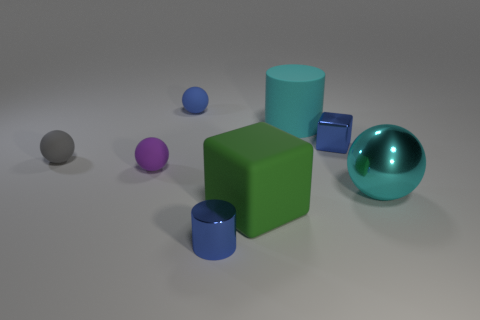Subtract all blue spheres. How many spheres are left? 3 Subtract all cylinders. How many objects are left? 6 Add 1 cyan balls. How many objects exist? 9 Subtract all cyan balls. How many balls are left? 3 Subtract 3 spheres. How many spheres are left? 1 Subtract all large cyan rubber spheres. Subtract all tiny spheres. How many objects are left? 5 Add 8 big cyan objects. How many big cyan objects are left? 10 Add 4 cyan spheres. How many cyan spheres exist? 5 Subtract 0 green cylinders. How many objects are left? 8 Subtract all gray cylinders. Subtract all gray cubes. How many cylinders are left? 2 